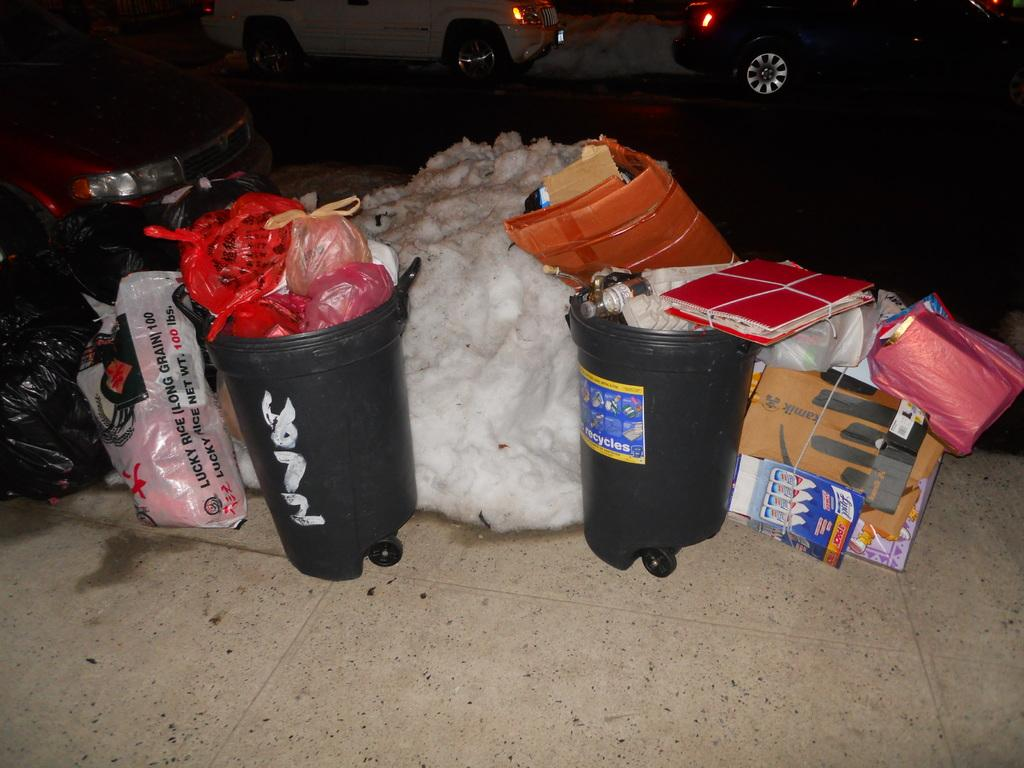<image>
Provide a brief description of the given image. A round trash bin has the word "recycles" on it, an sits with a bunch of other trash. 